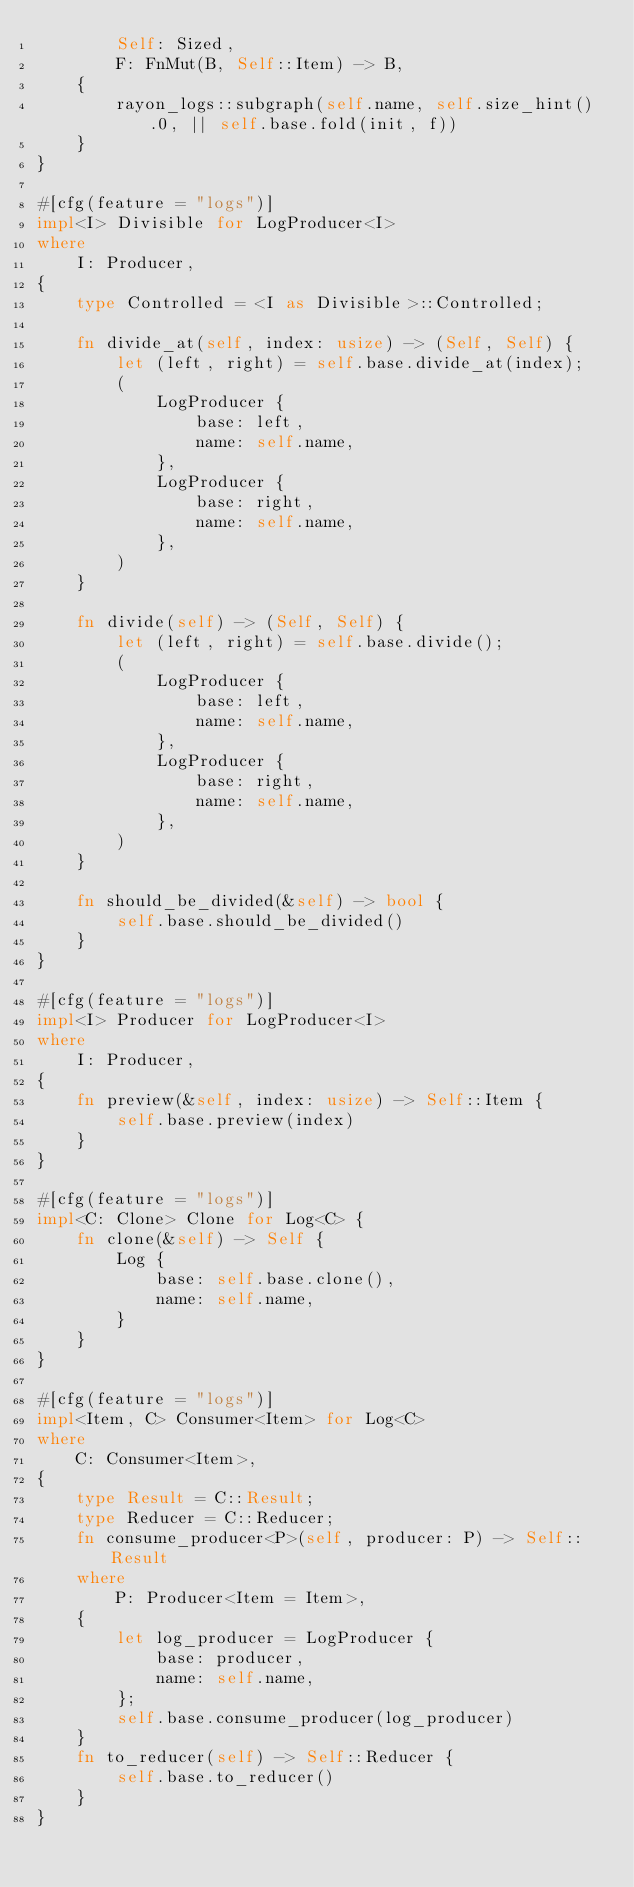<code> <loc_0><loc_0><loc_500><loc_500><_Rust_>        Self: Sized,
        F: FnMut(B, Self::Item) -> B,
    {
        rayon_logs::subgraph(self.name, self.size_hint().0, || self.base.fold(init, f))
    }
}

#[cfg(feature = "logs")]
impl<I> Divisible for LogProducer<I>
where
    I: Producer,
{
    type Controlled = <I as Divisible>::Controlled;

    fn divide_at(self, index: usize) -> (Self, Self) {
        let (left, right) = self.base.divide_at(index);
        (
            LogProducer {
                base: left,
                name: self.name,
            },
            LogProducer {
                base: right,
                name: self.name,
            },
        )
    }

    fn divide(self) -> (Self, Self) {
        let (left, right) = self.base.divide();
        (
            LogProducer {
                base: left,
                name: self.name,
            },
            LogProducer {
                base: right,
                name: self.name,
            },
        )
    }

    fn should_be_divided(&self) -> bool {
        self.base.should_be_divided()
    }
}

#[cfg(feature = "logs")]
impl<I> Producer for LogProducer<I>
where
    I: Producer,
{
    fn preview(&self, index: usize) -> Self::Item {
        self.base.preview(index)
    }
}

#[cfg(feature = "logs")]
impl<C: Clone> Clone for Log<C> {
    fn clone(&self) -> Self {
        Log {
            base: self.base.clone(),
            name: self.name,
        }
    }
}

#[cfg(feature = "logs")]
impl<Item, C> Consumer<Item> for Log<C>
where
    C: Consumer<Item>,
{
    type Result = C::Result;
    type Reducer = C::Reducer;
    fn consume_producer<P>(self, producer: P) -> Self::Result
    where
        P: Producer<Item = Item>,
    {
        let log_producer = LogProducer {
            base: producer,
            name: self.name,
        };
        self.base.consume_producer(log_producer)
    }
    fn to_reducer(self) -> Self::Reducer {
        self.base.to_reducer()
    }
}
</code> 